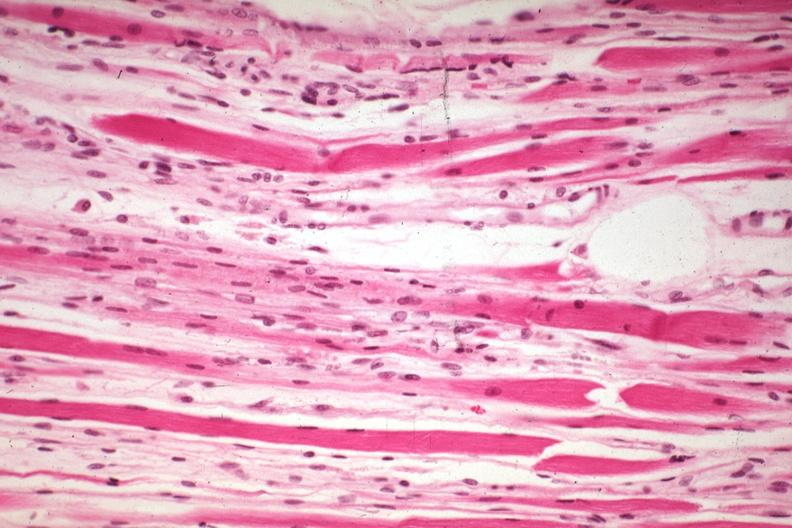s muscle present?
Answer the question using a single word or phrase. Yes 